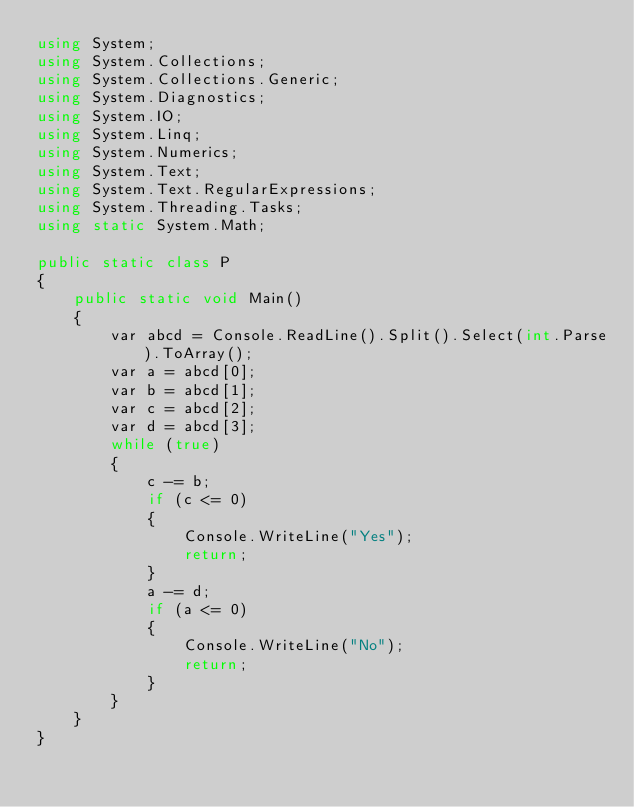Convert code to text. <code><loc_0><loc_0><loc_500><loc_500><_C#_>using System;
using System.Collections;
using System.Collections.Generic;
using System.Diagnostics;
using System.IO;
using System.Linq;
using System.Numerics;
using System.Text;
using System.Text.RegularExpressions;
using System.Threading.Tasks;
using static System.Math;

public static class P
{
    public static void Main()
    {
        var abcd = Console.ReadLine().Split().Select(int.Parse).ToArray();
        var a = abcd[0];
        var b = abcd[1];
        var c = abcd[2];
        var d = abcd[3];
        while (true)
        {
            c -= b;
            if (c <= 0)
            {
                Console.WriteLine("Yes");
                return;
            }
            a -= d;
            if (a <= 0)
            {
                Console.WriteLine("No");
                return;
            }
        }
    }
}</code> 